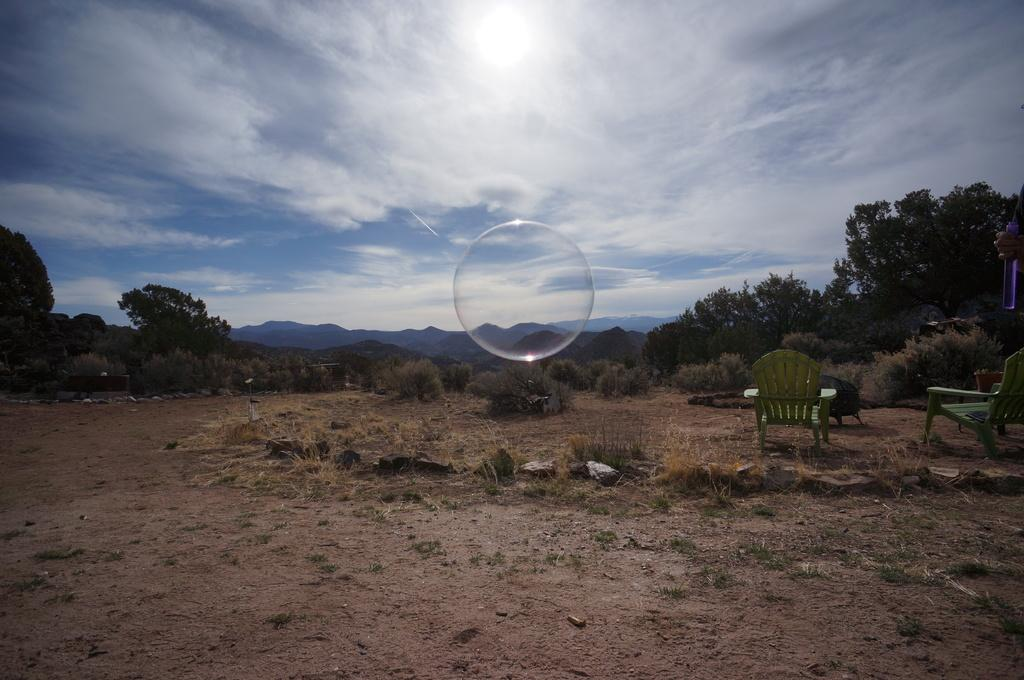What type of ground surface is visible in the image? There is grass and stones on the ground in the image. What type of furniture can be seen in the image? There are chairs in the image. What is the water bubble in the image? The water bubble is a small, spherical body of water in the image. What can be seen in the background of the image? There are hills, trees, and the sky visible in the background of the image. What is the condition of the sky in the image? The sky is visible in the background of the image, and clouds are present. What is the purpose of the store in the image? There is no store present in the image. 